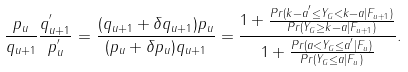Convert formula to latex. <formula><loc_0><loc_0><loc_500><loc_500>\frac { p _ { u } } { q _ { u + 1 } } { \frac { q ^ { ^ { \prime } } _ { u + 1 } } { p ^ { ^ { \prime } } _ { u } } } = \frac { ( q _ { u + 1 } + \delta q _ { u + 1 } ) p _ { u } } { ( p _ { u } + \delta p _ { u } ) q _ { u + 1 } } = \frac { 1 + \frac { P r ( k - a ^ { ^ { \prime } } \leq Y _ { G } < k - a | F _ { u + 1 } ) } { P r ( Y _ { G } \geq k - a | F _ { u + 1 } ) } } { 1 + \frac { P r ( a < Y _ { G } \leq a ^ { ^ { \prime } } | F _ { u } ) } { P r ( Y _ { G } \leq a | F _ { u } ) } } .</formula> 